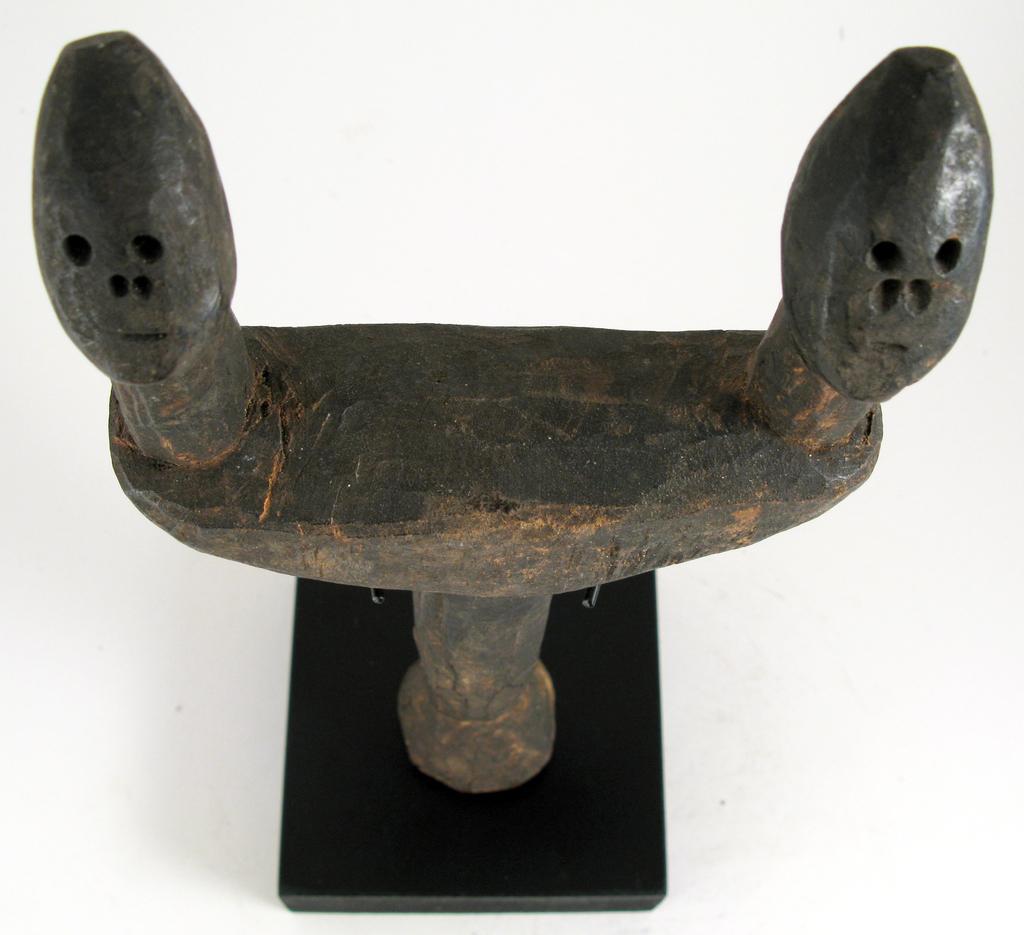In one or two sentences, can you explain what this image depicts? In this picture we can see a bronze sculpture, there is a plane background. 